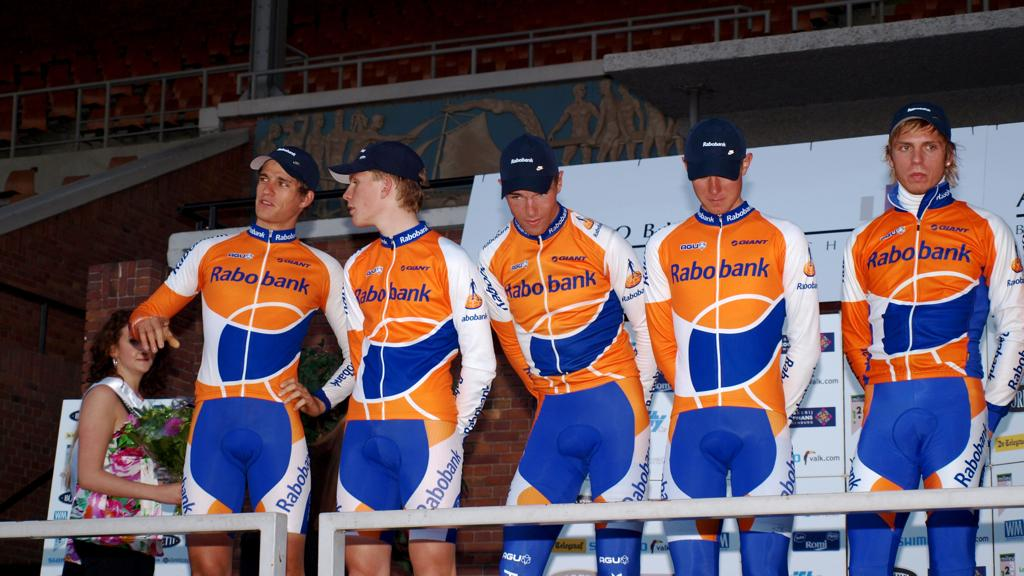Provide a one-sentence caption for the provided image. Five men wearing a jumpsuit with Rabo bank written on it. 